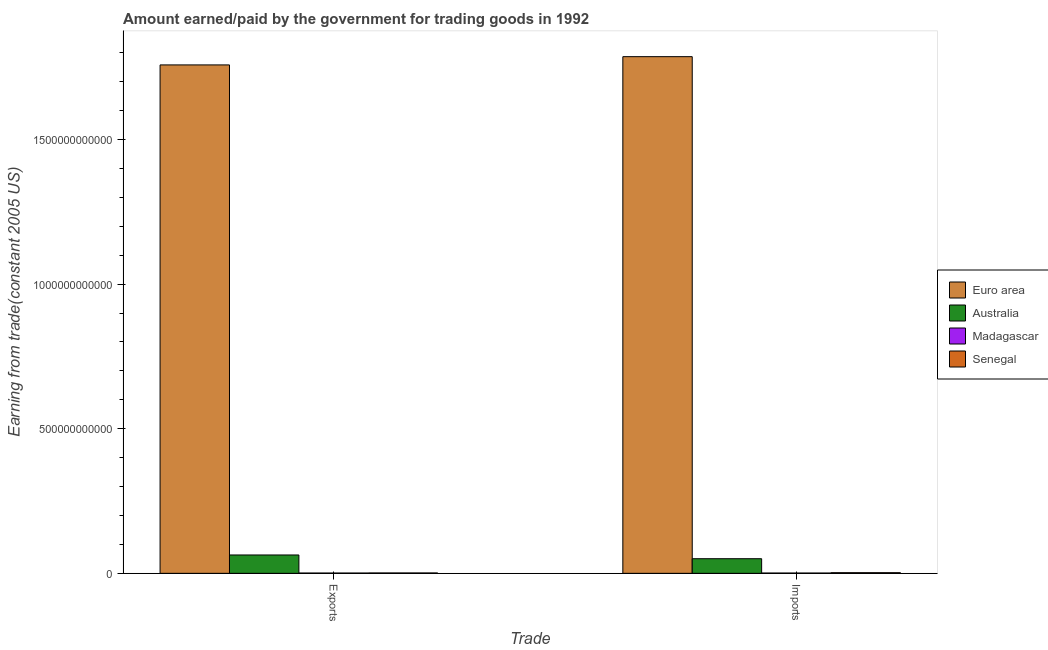How many different coloured bars are there?
Keep it short and to the point. 4. How many groups of bars are there?
Offer a very short reply. 2. Are the number of bars per tick equal to the number of legend labels?
Keep it short and to the point. Yes. What is the label of the 1st group of bars from the left?
Provide a succinct answer. Exports. What is the amount earned from exports in Madagascar?
Give a very brief answer. 1.02e+09. Across all countries, what is the maximum amount paid for imports?
Provide a succinct answer. 1.79e+12. Across all countries, what is the minimum amount paid for imports?
Your response must be concise. 1.03e+09. In which country was the amount paid for imports minimum?
Provide a short and direct response. Madagascar. What is the total amount paid for imports in the graph?
Ensure brevity in your answer.  1.84e+12. What is the difference between the amount paid for imports in Madagascar and that in Euro area?
Provide a short and direct response. -1.79e+12. What is the difference between the amount earned from exports in Australia and the amount paid for imports in Senegal?
Offer a very short reply. 6.12e+1. What is the average amount earned from exports per country?
Make the answer very short. 4.56e+11. What is the difference between the amount earned from exports and amount paid for imports in Australia?
Make the answer very short. 1.29e+1. What is the ratio of the amount earned from exports in Madagascar to that in Australia?
Your response must be concise. 0.02. In how many countries, is the amount earned from exports greater than the average amount earned from exports taken over all countries?
Provide a short and direct response. 1. What does the 1st bar from the left in Imports represents?
Your answer should be compact. Euro area. What is the difference between two consecutive major ticks on the Y-axis?
Give a very brief answer. 5.00e+11. Are the values on the major ticks of Y-axis written in scientific E-notation?
Your answer should be very brief. No. Does the graph contain any zero values?
Provide a short and direct response. No. How many legend labels are there?
Give a very brief answer. 4. How are the legend labels stacked?
Provide a succinct answer. Vertical. What is the title of the graph?
Ensure brevity in your answer.  Amount earned/paid by the government for trading goods in 1992. What is the label or title of the X-axis?
Provide a succinct answer. Trade. What is the label or title of the Y-axis?
Provide a succinct answer. Earning from trade(constant 2005 US). What is the Earning from trade(constant 2005 US) of Euro area in Exports?
Keep it short and to the point. 1.76e+12. What is the Earning from trade(constant 2005 US) in Australia in Exports?
Your response must be concise. 6.35e+1. What is the Earning from trade(constant 2005 US) in Madagascar in Exports?
Your answer should be compact. 1.02e+09. What is the Earning from trade(constant 2005 US) of Senegal in Exports?
Offer a very short reply. 1.33e+09. What is the Earning from trade(constant 2005 US) of Euro area in Imports?
Offer a terse response. 1.79e+12. What is the Earning from trade(constant 2005 US) of Australia in Imports?
Provide a succinct answer. 5.06e+1. What is the Earning from trade(constant 2005 US) in Madagascar in Imports?
Provide a succinct answer. 1.03e+09. What is the Earning from trade(constant 2005 US) in Senegal in Imports?
Provide a succinct answer. 2.28e+09. Across all Trade, what is the maximum Earning from trade(constant 2005 US) of Euro area?
Your answer should be very brief. 1.79e+12. Across all Trade, what is the maximum Earning from trade(constant 2005 US) of Australia?
Offer a very short reply. 6.35e+1. Across all Trade, what is the maximum Earning from trade(constant 2005 US) in Madagascar?
Make the answer very short. 1.03e+09. Across all Trade, what is the maximum Earning from trade(constant 2005 US) of Senegal?
Make the answer very short. 2.28e+09. Across all Trade, what is the minimum Earning from trade(constant 2005 US) in Euro area?
Keep it short and to the point. 1.76e+12. Across all Trade, what is the minimum Earning from trade(constant 2005 US) of Australia?
Provide a short and direct response. 5.06e+1. Across all Trade, what is the minimum Earning from trade(constant 2005 US) in Madagascar?
Provide a short and direct response. 1.02e+09. Across all Trade, what is the minimum Earning from trade(constant 2005 US) in Senegal?
Provide a short and direct response. 1.33e+09. What is the total Earning from trade(constant 2005 US) in Euro area in the graph?
Offer a very short reply. 3.54e+12. What is the total Earning from trade(constant 2005 US) of Australia in the graph?
Provide a short and direct response. 1.14e+11. What is the total Earning from trade(constant 2005 US) in Madagascar in the graph?
Your answer should be very brief. 2.05e+09. What is the total Earning from trade(constant 2005 US) in Senegal in the graph?
Make the answer very short. 3.61e+09. What is the difference between the Earning from trade(constant 2005 US) in Euro area in Exports and that in Imports?
Ensure brevity in your answer.  -2.85e+1. What is the difference between the Earning from trade(constant 2005 US) of Australia in Exports and that in Imports?
Offer a terse response. 1.29e+1. What is the difference between the Earning from trade(constant 2005 US) of Madagascar in Exports and that in Imports?
Provide a succinct answer. -1.16e+07. What is the difference between the Earning from trade(constant 2005 US) of Senegal in Exports and that in Imports?
Offer a very short reply. -9.46e+08. What is the difference between the Earning from trade(constant 2005 US) of Euro area in Exports and the Earning from trade(constant 2005 US) of Australia in Imports?
Provide a short and direct response. 1.71e+12. What is the difference between the Earning from trade(constant 2005 US) of Euro area in Exports and the Earning from trade(constant 2005 US) of Madagascar in Imports?
Offer a very short reply. 1.76e+12. What is the difference between the Earning from trade(constant 2005 US) in Euro area in Exports and the Earning from trade(constant 2005 US) in Senegal in Imports?
Provide a succinct answer. 1.76e+12. What is the difference between the Earning from trade(constant 2005 US) in Australia in Exports and the Earning from trade(constant 2005 US) in Madagascar in Imports?
Ensure brevity in your answer.  6.25e+1. What is the difference between the Earning from trade(constant 2005 US) of Australia in Exports and the Earning from trade(constant 2005 US) of Senegal in Imports?
Keep it short and to the point. 6.12e+1. What is the difference between the Earning from trade(constant 2005 US) in Madagascar in Exports and the Earning from trade(constant 2005 US) in Senegal in Imports?
Give a very brief answer. -1.26e+09. What is the average Earning from trade(constant 2005 US) of Euro area per Trade?
Your response must be concise. 1.77e+12. What is the average Earning from trade(constant 2005 US) of Australia per Trade?
Ensure brevity in your answer.  5.70e+1. What is the average Earning from trade(constant 2005 US) in Madagascar per Trade?
Offer a very short reply. 1.03e+09. What is the average Earning from trade(constant 2005 US) of Senegal per Trade?
Make the answer very short. 1.80e+09. What is the difference between the Earning from trade(constant 2005 US) of Euro area and Earning from trade(constant 2005 US) of Australia in Exports?
Give a very brief answer. 1.69e+12. What is the difference between the Earning from trade(constant 2005 US) in Euro area and Earning from trade(constant 2005 US) in Madagascar in Exports?
Keep it short and to the point. 1.76e+12. What is the difference between the Earning from trade(constant 2005 US) in Euro area and Earning from trade(constant 2005 US) in Senegal in Exports?
Your response must be concise. 1.76e+12. What is the difference between the Earning from trade(constant 2005 US) in Australia and Earning from trade(constant 2005 US) in Madagascar in Exports?
Ensure brevity in your answer.  6.25e+1. What is the difference between the Earning from trade(constant 2005 US) in Australia and Earning from trade(constant 2005 US) in Senegal in Exports?
Offer a terse response. 6.22e+1. What is the difference between the Earning from trade(constant 2005 US) of Madagascar and Earning from trade(constant 2005 US) of Senegal in Exports?
Offer a very short reply. -3.12e+08. What is the difference between the Earning from trade(constant 2005 US) in Euro area and Earning from trade(constant 2005 US) in Australia in Imports?
Give a very brief answer. 1.74e+12. What is the difference between the Earning from trade(constant 2005 US) in Euro area and Earning from trade(constant 2005 US) in Madagascar in Imports?
Provide a short and direct response. 1.79e+12. What is the difference between the Earning from trade(constant 2005 US) of Euro area and Earning from trade(constant 2005 US) of Senegal in Imports?
Keep it short and to the point. 1.78e+12. What is the difference between the Earning from trade(constant 2005 US) in Australia and Earning from trade(constant 2005 US) in Madagascar in Imports?
Give a very brief answer. 4.96e+1. What is the difference between the Earning from trade(constant 2005 US) in Australia and Earning from trade(constant 2005 US) in Senegal in Imports?
Give a very brief answer. 4.83e+1. What is the difference between the Earning from trade(constant 2005 US) of Madagascar and Earning from trade(constant 2005 US) of Senegal in Imports?
Your answer should be compact. -1.25e+09. What is the ratio of the Earning from trade(constant 2005 US) in Australia in Exports to that in Imports?
Your answer should be compact. 1.26. What is the ratio of the Earning from trade(constant 2005 US) of Madagascar in Exports to that in Imports?
Your answer should be very brief. 0.99. What is the ratio of the Earning from trade(constant 2005 US) of Senegal in Exports to that in Imports?
Keep it short and to the point. 0.58. What is the difference between the highest and the second highest Earning from trade(constant 2005 US) of Euro area?
Keep it short and to the point. 2.85e+1. What is the difference between the highest and the second highest Earning from trade(constant 2005 US) in Australia?
Your answer should be very brief. 1.29e+1. What is the difference between the highest and the second highest Earning from trade(constant 2005 US) in Madagascar?
Give a very brief answer. 1.16e+07. What is the difference between the highest and the second highest Earning from trade(constant 2005 US) of Senegal?
Your answer should be very brief. 9.46e+08. What is the difference between the highest and the lowest Earning from trade(constant 2005 US) in Euro area?
Ensure brevity in your answer.  2.85e+1. What is the difference between the highest and the lowest Earning from trade(constant 2005 US) in Australia?
Your answer should be compact. 1.29e+1. What is the difference between the highest and the lowest Earning from trade(constant 2005 US) in Madagascar?
Keep it short and to the point. 1.16e+07. What is the difference between the highest and the lowest Earning from trade(constant 2005 US) in Senegal?
Give a very brief answer. 9.46e+08. 